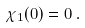<formula> <loc_0><loc_0><loc_500><loc_500>\chi _ { 1 } ( 0 ) = 0 \, .</formula> 